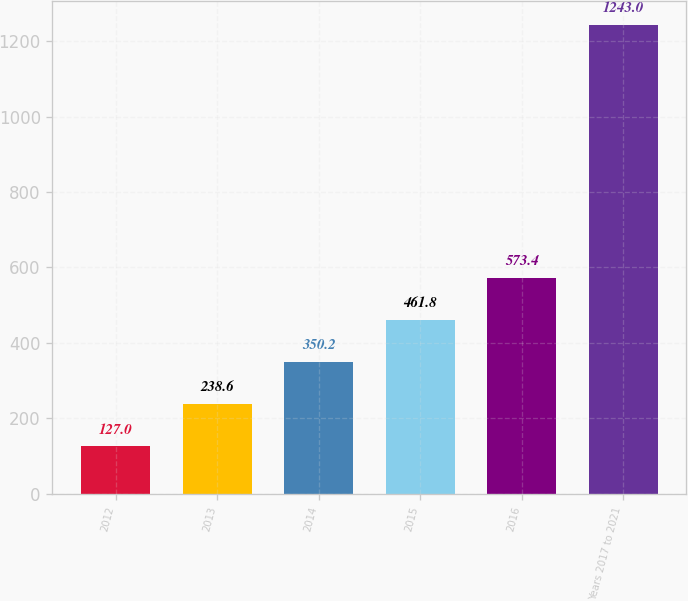Convert chart. <chart><loc_0><loc_0><loc_500><loc_500><bar_chart><fcel>2012<fcel>2013<fcel>2014<fcel>2015<fcel>2016<fcel>Years 2017 to 2021<nl><fcel>127<fcel>238.6<fcel>350.2<fcel>461.8<fcel>573.4<fcel>1243<nl></chart> 